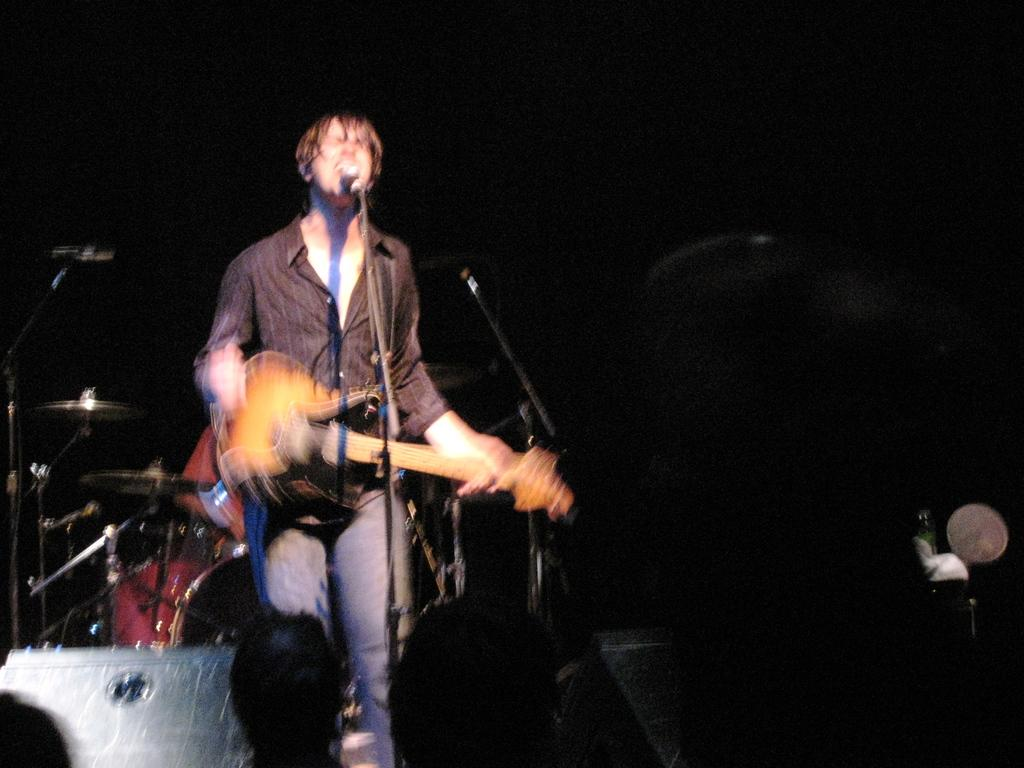Who is the main subject in the image? There is a man in the image. What is the man doing in the image? The man is standing and holding a guitar in his hand. Are there any other people in the image? Yes, there are other people in the image. What are the other people doing in the image? The other people are watching the man with the guitar. Where is the airplane located in the image? There is no airplane present in the image. What type of chair is the man sitting on while playing the guitar? The man is standing, not sitting, and there is no chair mentioned in the image. 